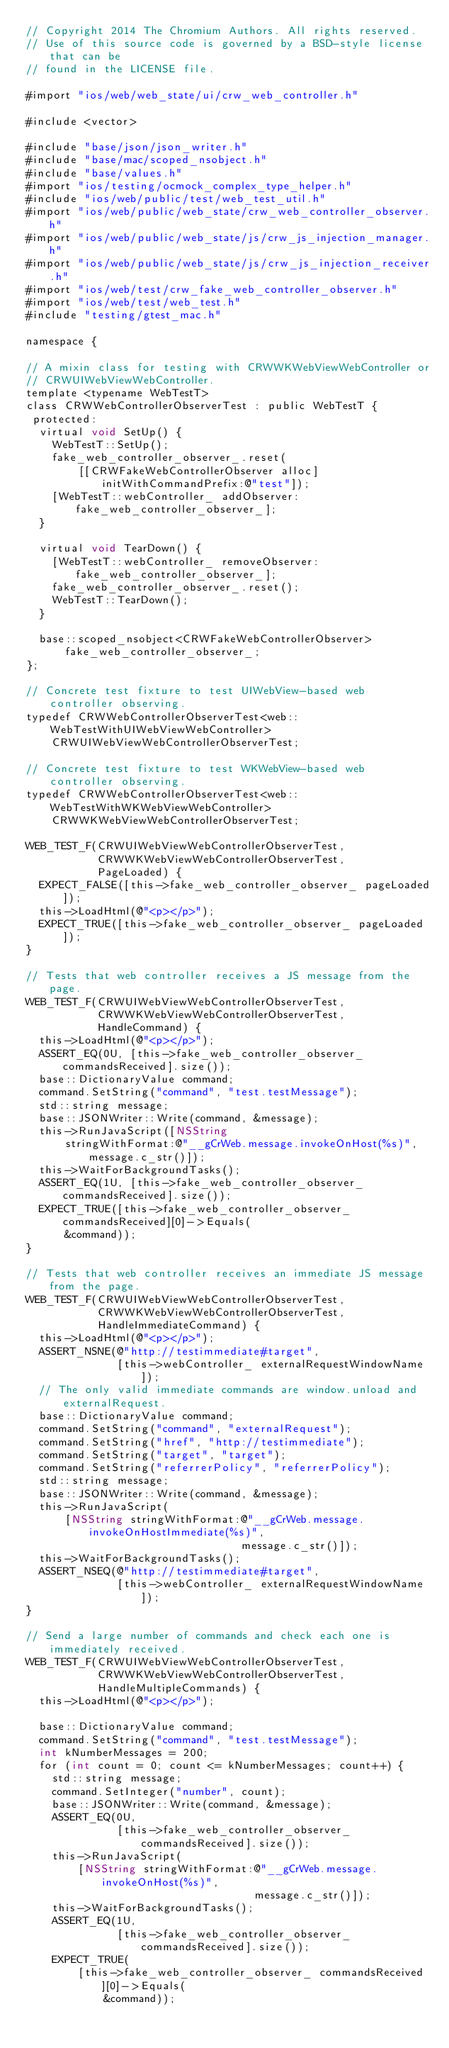Convert code to text. <code><loc_0><loc_0><loc_500><loc_500><_ObjectiveC_>// Copyright 2014 The Chromium Authors. All rights reserved.
// Use of this source code is governed by a BSD-style license that can be
// found in the LICENSE file.

#import "ios/web/web_state/ui/crw_web_controller.h"

#include <vector>

#include "base/json/json_writer.h"
#include "base/mac/scoped_nsobject.h"
#include "base/values.h"
#import "ios/testing/ocmock_complex_type_helper.h"
#include "ios/web/public/test/web_test_util.h"
#import "ios/web/public/web_state/crw_web_controller_observer.h"
#import "ios/web/public/web_state/js/crw_js_injection_manager.h"
#import "ios/web/public/web_state/js/crw_js_injection_receiver.h"
#import "ios/web/test/crw_fake_web_controller_observer.h"
#import "ios/web/test/web_test.h"
#include "testing/gtest_mac.h"

namespace {

// A mixin class for testing with CRWWKWebViewWebController or
// CRWUIWebViewWebController.
template <typename WebTestT>
class CRWWebControllerObserverTest : public WebTestT {
 protected:
  virtual void SetUp() {
    WebTestT::SetUp();
    fake_web_controller_observer_.reset(
        [[CRWFakeWebControllerObserver alloc] initWithCommandPrefix:@"test"]);
    [WebTestT::webController_ addObserver:fake_web_controller_observer_];
  }

  virtual void TearDown() {
    [WebTestT::webController_ removeObserver:fake_web_controller_observer_];
    fake_web_controller_observer_.reset();
    WebTestT::TearDown();
  }

  base::scoped_nsobject<CRWFakeWebControllerObserver>
      fake_web_controller_observer_;
};

// Concrete test fixture to test UIWebView-based web controller observing.
typedef CRWWebControllerObserverTest<web::WebTestWithUIWebViewWebController>
    CRWUIWebViewWebControllerObserverTest;

// Concrete test fixture to test WKWebView-based web controller observing.
typedef CRWWebControllerObserverTest<web::WebTestWithWKWebViewWebController>
    CRWWKWebViewWebControllerObserverTest;

WEB_TEST_F(CRWUIWebViewWebControllerObserverTest,
           CRWWKWebViewWebControllerObserverTest,
           PageLoaded) {
  EXPECT_FALSE([this->fake_web_controller_observer_ pageLoaded]);
  this->LoadHtml(@"<p></p>");
  EXPECT_TRUE([this->fake_web_controller_observer_ pageLoaded]);
}

// Tests that web controller receives a JS message from the page.
WEB_TEST_F(CRWUIWebViewWebControllerObserverTest,
           CRWWKWebViewWebControllerObserverTest,
           HandleCommand) {
  this->LoadHtml(@"<p></p>");
  ASSERT_EQ(0U, [this->fake_web_controller_observer_ commandsReceived].size());
  base::DictionaryValue command;
  command.SetString("command", "test.testMessage");
  std::string message;
  base::JSONWriter::Write(command, &message);
  this->RunJavaScript([NSString
      stringWithFormat:@"__gCrWeb.message.invokeOnHost(%s)", message.c_str()]);
  this->WaitForBackgroundTasks();
  ASSERT_EQ(1U, [this->fake_web_controller_observer_ commandsReceived].size());
  EXPECT_TRUE([this->fake_web_controller_observer_ commandsReceived][0]->Equals(
      &command));
}

// Tests that web controller receives an immediate JS message from the page.
WEB_TEST_F(CRWUIWebViewWebControllerObserverTest,
           CRWWKWebViewWebControllerObserverTest,
           HandleImmediateCommand) {
  this->LoadHtml(@"<p></p>");
  ASSERT_NSNE(@"http://testimmediate#target",
              [this->webController_ externalRequestWindowName]);
  // The only valid immediate commands are window.unload and externalRequest.
  base::DictionaryValue command;
  command.SetString("command", "externalRequest");
  command.SetString("href", "http://testimmediate");
  command.SetString("target", "target");
  command.SetString("referrerPolicy", "referrerPolicy");
  std::string message;
  base::JSONWriter::Write(command, &message);
  this->RunJavaScript(
      [NSString stringWithFormat:@"__gCrWeb.message.invokeOnHostImmediate(%s)",
                                 message.c_str()]);
  this->WaitForBackgroundTasks();
  ASSERT_NSEQ(@"http://testimmediate#target",
              [this->webController_ externalRequestWindowName]);
}

// Send a large number of commands and check each one is immediately received.
WEB_TEST_F(CRWUIWebViewWebControllerObserverTest,
           CRWWKWebViewWebControllerObserverTest,
           HandleMultipleCommands) {
  this->LoadHtml(@"<p></p>");

  base::DictionaryValue command;
  command.SetString("command", "test.testMessage");
  int kNumberMessages = 200;
  for (int count = 0; count <= kNumberMessages; count++) {
    std::string message;
    command.SetInteger("number", count);
    base::JSONWriter::Write(command, &message);
    ASSERT_EQ(0U,
              [this->fake_web_controller_observer_ commandsReceived].size());
    this->RunJavaScript(
        [NSString stringWithFormat:@"__gCrWeb.message.invokeOnHost(%s)",
                                   message.c_str()]);
    this->WaitForBackgroundTasks();
    ASSERT_EQ(1U,
              [this->fake_web_controller_observer_ commandsReceived].size());
    EXPECT_TRUE(
        [this->fake_web_controller_observer_ commandsReceived][0]->Equals(
            &command));</code> 